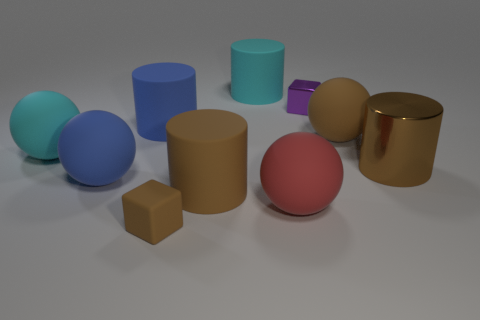There is a purple shiny block; is its size the same as the brown rubber thing that is in front of the red rubber sphere?
Provide a short and direct response. Yes. What is the size of the brown cylinder on the left side of the big rubber cylinder behind the purple metal cube?
Provide a succinct answer. Large. What number of blue objects are made of the same material as the large cyan ball?
Ensure brevity in your answer.  2. Are any tiny gray blocks visible?
Your answer should be very brief. No. What size is the cyan matte object that is on the left side of the large blue ball?
Keep it short and to the point. Large. How many large metallic things have the same color as the tiny rubber object?
Offer a terse response. 1. How many cylinders are either big red matte things or brown objects?
Make the answer very short. 2. The brown thing that is right of the tiny brown object and in front of the big shiny object has what shape?
Provide a short and direct response. Cylinder. Is there a metallic cube of the same size as the red rubber object?
Offer a terse response. No. What number of things are either cubes that are in front of the large red thing or small cyan matte objects?
Provide a succinct answer. 1. 